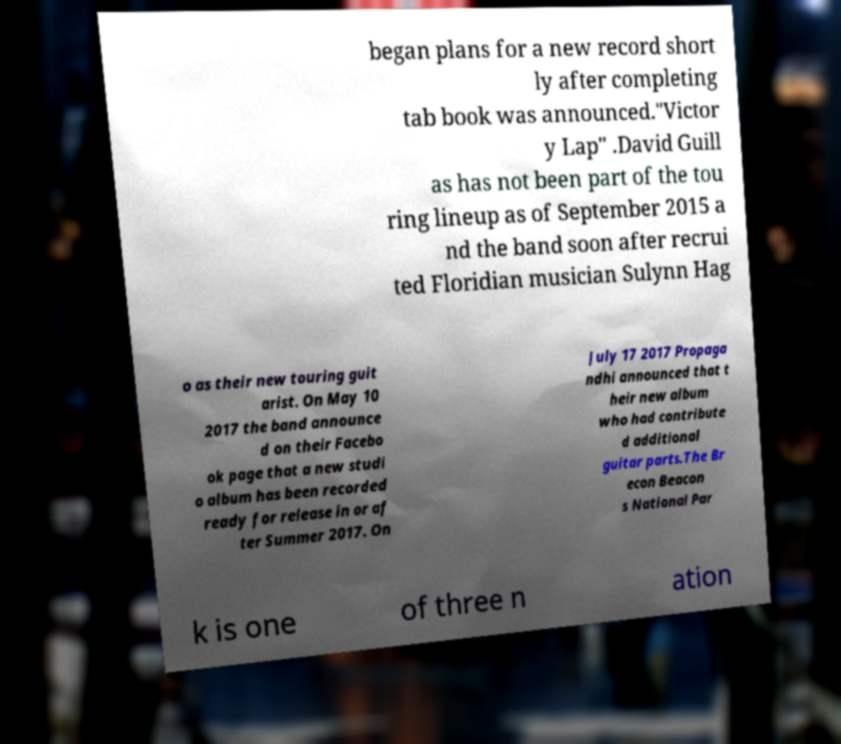Can you accurately transcribe the text from the provided image for me? began plans for a new record short ly after completing tab book was announced."Victor y Lap" .David Guill as has not been part of the tou ring lineup as of September 2015 a nd the band soon after recrui ted Floridian musician Sulynn Hag o as their new touring guit arist. On May 10 2017 the band announce d on their Facebo ok page that a new studi o album has been recorded ready for release in or af ter Summer 2017. On July 17 2017 Propaga ndhi announced that t heir new album who had contribute d additional guitar parts.The Br econ Beacon s National Par k is one of three n ation 